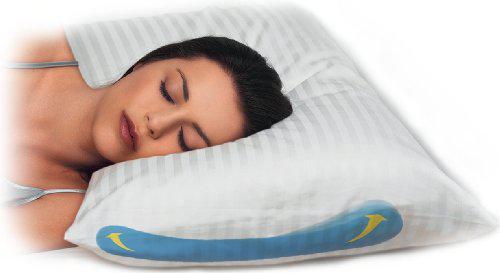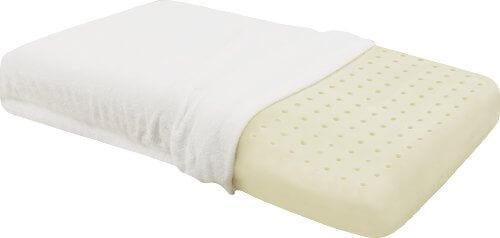The first image is the image on the left, the second image is the image on the right. Evaluate the accuracy of this statement regarding the images: "In one image, a woman with dark hair rests her head on a pillow". Is it true? Answer yes or no. Yes. The first image is the image on the left, the second image is the image on the right. Given the left and right images, does the statement "A brunette woman is sleeping on a pillow" hold true? Answer yes or no. Yes. 